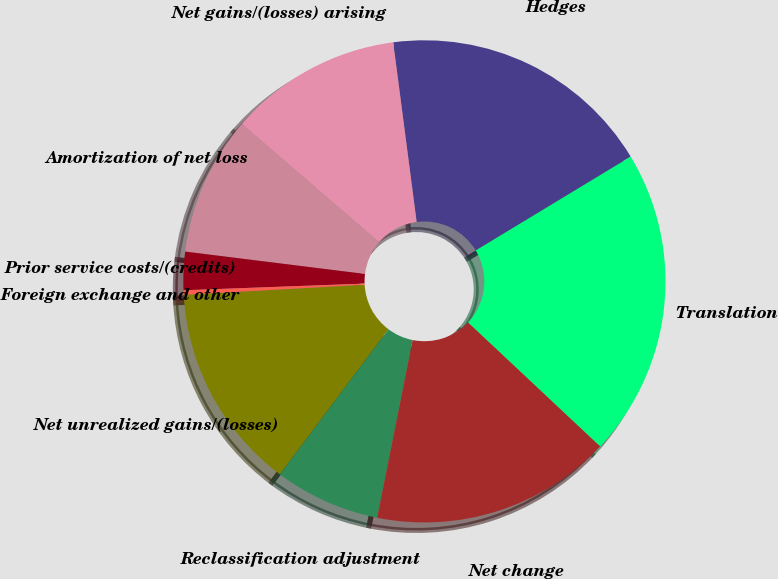Convert chart to OTSL. <chart><loc_0><loc_0><loc_500><loc_500><pie_chart><fcel>Net unrealized gains/(losses)<fcel>Reclassification adjustment<fcel>Net change<fcel>Translation<fcel>Hedges<fcel>Net gains/(losses) arising<fcel>Amortization of net loss<fcel>Prior service costs/(credits)<fcel>Foreign exchange and other<nl><fcel>13.88%<fcel>7.09%<fcel>16.14%<fcel>20.66%<fcel>18.4%<fcel>11.61%<fcel>9.35%<fcel>2.56%<fcel>0.3%<nl></chart> 